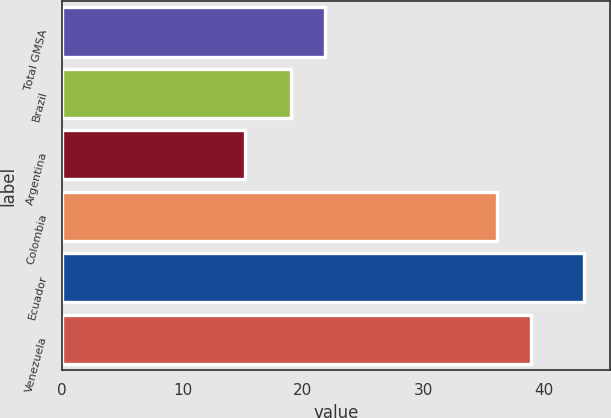Convert chart to OTSL. <chart><loc_0><loc_0><loc_500><loc_500><bar_chart><fcel>Total GMSA<fcel>Brazil<fcel>Argentina<fcel>Colombia<fcel>Ecuador<fcel>Venezuela<nl><fcel>21.81<fcel>19<fcel>15.2<fcel>36.1<fcel>43.3<fcel>38.91<nl></chart> 